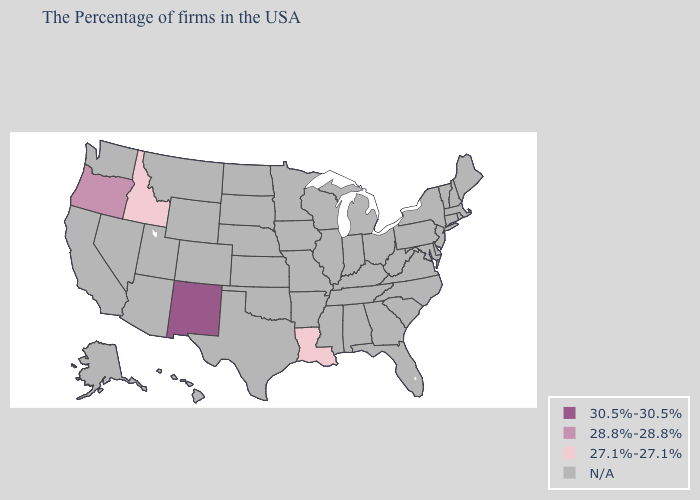Name the states that have a value in the range N/A?
Be succinct. Maine, Massachusetts, Rhode Island, New Hampshire, Vermont, Connecticut, New York, New Jersey, Delaware, Maryland, Pennsylvania, Virginia, North Carolina, South Carolina, West Virginia, Ohio, Florida, Georgia, Michigan, Kentucky, Indiana, Alabama, Tennessee, Wisconsin, Illinois, Mississippi, Missouri, Arkansas, Minnesota, Iowa, Kansas, Nebraska, Oklahoma, Texas, South Dakota, North Dakota, Wyoming, Colorado, Utah, Montana, Arizona, Nevada, California, Washington, Alaska, Hawaii. Name the states that have a value in the range N/A?
Concise answer only. Maine, Massachusetts, Rhode Island, New Hampshire, Vermont, Connecticut, New York, New Jersey, Delaware, Maryland, Pennsylvania, Virginia, North Carolina, South Carolina, West Virginia, Ohio, Florida, Georgia, Michigan, Kentucky, Indiana, Alabama, Tennessee, Wisconsin, Illinois, Mississippi, Missouri, Arkansas, Minnesota, Iowa, Kansas, Nebraska, Oklahoma, Texas, South Dakota, North Dakota, Wyoming, Colorado, Utah, Montana, Arizona, Nevada, California, Washington, Alaska, Hawaii. Name the states that have a value in the range 28.8%-28.8%?
Quick response, please. Oregon. Name the states that have a value in the range 27.1%-27.1%?
Be succinct. Louisiana, Idaho. Among the states that border Utah , which have the lowest value?
Concise answer only. Idaho. Name the states that have a value in the range N/A?
Concise answer only. Maine, Massachusetts, Rhode Island, New Hampshire, Vermont, Connecticut, New York, New Jersey, Delaware, Maryland, Pennsylvania, Virginia, North Carolina, South Carolina, West Virginia, Ohio, Florida, Georgia, Michigan, Kentucky, Indiana, Alabama, Tennessee, Wisconsin, Illinois, Mississippi, Missouri, Arkansas, Minnesota, Iowa, Kansas, Nebraska, Oklahoma, Texas, South Dakota, North Dakota, Wyoming, Colorado, Utah, Montana, Arizona, Nevada, California, Washington, Alaska, Hawaii. What is the lowest value in the USA?
Concise answer only. 27.1%-27.1%. What is the value of Louisiana?
Short answer required. 27.1%-27.1%. Name the states that have a value in the range 28.8%-28.8%?
Answer briefly. Oregon. Name the states that have a value in the range 30.5%-30.5%?
Answer briefly. New Mexico. Name the states that have a value in the range 27.1%-27.1%?
Give a very brief answer. Louisiana, Idaho. What is the value of New Hampshire?
Answer briefly. N/A. 